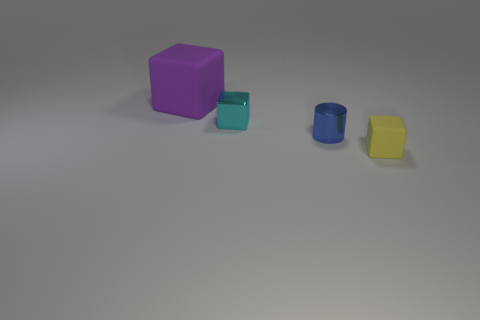Does the tiny rubber thing have the same shape as the blue metallic object?
Offer a terse response. No. There is a matte thing that is right of the rubber object that is behind the matte object that is on the right side of the purple rubber block; how big is it?
Your answer should be compact. Small. What is the material of the small cyan object?
Provide a succinct answer. Metal. There is a big object; does it have the same shape as the blue metal object behind the yellow object?
Ensure brevity in your answer.  No. The cube on the right side of the shiny object that is left of the tiny metal thing that is in front of the metallic cube is made of what material?
Make the answer very short. Rubber. How many red matte cylinders are there?
Provide a succinct answer. 0. What number of purple things are matte objects or large metallic balls?
Your answer should be very brief. 1. How many other objects are the same shape as the big object?
Your response must be concise. 2. There is a rubber thing that is in front of the purple block; is it the same color as the tiny cube to the left of the tiny yellow cube?
Offer a very short reply. No. What number of small things are cylinders or cyan shiny objects?
Keep it short and to the point. 2. 